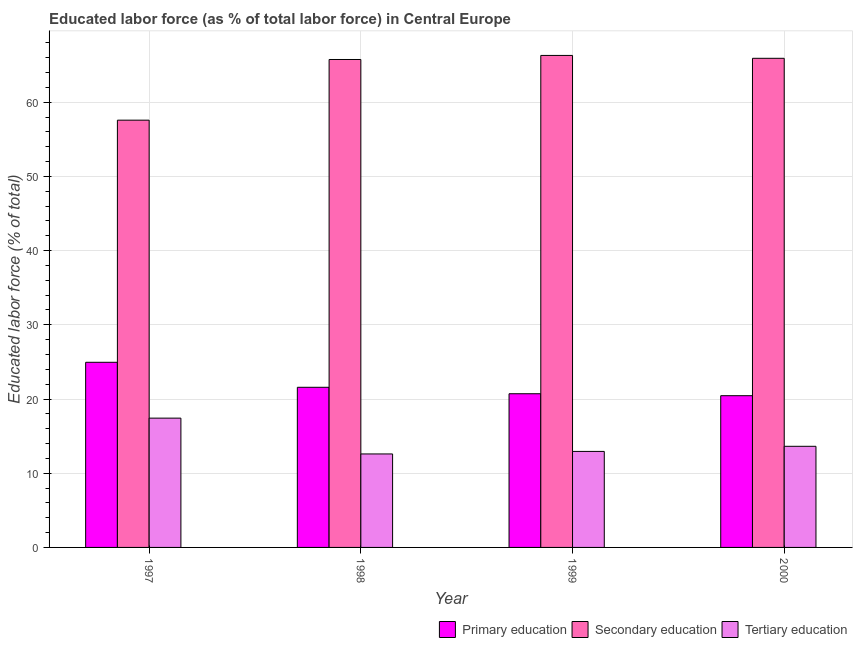How many different coloured bars are there?
Give a very brief answer. 3. Are the number of bars on each tick of the X-axis equal?
Give a very brief answer. Yes. How many bars are there on the 3rd tick from the right?
Offer a terse response. 3. What is the label of the 3rd group of bars from the left?
Offer a very short reply. 1999. What is the percentage of labor force who received primary education in 1997?
Your response must be concise. 24.95. Across all years, what is the maximum percentage of labor force who received tertiary education?
Provide a short and direct response. 17.42. Across all years, what is the minimum percentage of labor force who received tertiary education?
Offer a very short reply. 12.6. In which year was the percentage of labor force who received secondary education maximum?
Offer a very short reply. 1999. What is the total percentage of labor force who received primary education in the graph?
Your response must be concise. 87.69. What is the difference between the percentage of labor force who received secondary education in 1999 and that in 2000?
Provide a succinct answer. 0.39. What is the difference between the percentage of labor force who received tertiary education in 1999 and the percentage of labor force who received primary education in 1998?
Your response must be concise. 0.34. What is the average percentage of labor force who received primary education per year?
Provide a short and direct response. 21.92. In how many years, is the percentage of labor force who received secondary education greater than 24 %?
Keep it short and to the point. 4. What is the ratio of the percentage of labor force who received secondary education in 1997 to that in 1998?
Your answer should be compact. 0.88. What is the difference between the highest and the second highest percentage of labor force who received tertiary education?
Your answer should be very brief. 3.8. What is the difference between the highest and the lowest percentage of labor force who received secondary education?
Provide a short and direct response. 8.72. What does the 2nd bar from the left in 1999 represents?
Your answer should be compact. Secondary education. What does the 1st bar from the right in 1997 represents?
Your answer should be very brief. Tertiary education. Is it the case that in every year, the sum of the percentage of labor force who received primary education and percentage of labor force who received secondary education is greater than the percentage of labor force who received tertiary education?
Offer a terse response. Yes. How many years are there in the graph?
Keep it short and to the point. 4. Are the values on the major ticks of Y-axis written in scientific E-notation?
Make the answer very short. No. Does the graph contain grids?
Provide a short and direct response. Yes. How are the legend labels stacked?
Your answer should be compact. Horizontal. What is the title of the graph?
Provide a succinct answer. Educated labor force (as % of total labor force) in Central Europe. Does "Machinery" appear as one of the legend labels in the graph?
Keep it short and to the point. No. What is the label or title of the X-axis?
Provide a succinct answer. Year. What is the label or title of the Y-axis?
Ensure brevity in your answer.  Educated labor force (% of total). What is the Educated labor force (% of total) of Primary education in 1997?
Offer a very short reply. 24.95. What is the Educated labor force (% of total) of Secondary education in 1997?
Your response must be concise. 57.58. What is the Educated labor force (% of total) of Tertiary education in 1997?
Provide a short and direct response. 17.42. What is the Educated labor force (% of total) of Primary education in 1998?
Provide a succinct answer. 21.58. What is the Educated labor force (% of total) of Secondary education in 1998?
Keep it short and to the point. 65.76. What is the Educated labor force (% of total) in Tertiary education in 1998?
Your answer should be compact. 12.6. What is the Educated labor force (% of total) of Primary education in 1999?
Make the answer very short. 20.71. What is the Educated labor force (% of total) in Secondary education in 1999?
Your response must be concise. 66.3. What is the Educated labor force (% of total) of Tertiary education in 1999?
Offer a terse response. 12.94. What is the Educated labor force (% of total) of Primary education in 2000?
Your answer should be very brief. 20.45. What is the Educated labor force (% of total) of Secondary education in 2000?
Provide a short and direct response. 65.91. What is the Educated labor force (% of total) of Tertiary education in 2000?
Offer a terse response. 13.63. Across all years, what is the maximum Educated labor force (% of total) in Primary education?
Your answer should be compact. 24.95. Across all years, what is the maximum Educated labor force (% of total) in Secondary education?
Keep it short and to the point. 66.3. Across all years, what is the maximum Educated labor force (% of total) in Tertiary education?
Give a very brief answer. 17.42. Across all years, what is the minimum Educated labor force (% of total) of Primary education?
Keep it short and to the point. 20.45. Across all years, what is the minimum Educated labor force (% of total) of Secondary education?
Provide a succinct answer. 57.58. Across all years, what is the minimum Educated labor force (% of total) in Tertiary education?
Your answer should be compact. 12.6. What is the total Educated labor force (% of total) of Primary education in the graph?
Make the answer very short. 87.69. What is the total Educated labor force (% of total) of Secondary education in the graph?
Make the answer very short. 255.55. What is the total Educated labor force (% of total) in Tertiary education in the graph?
Offer a terse response. 56.59. What is the difference between the Educated labor force (% of total) in Primary education in 1997 and that in 1998?
Give a very brief answer. 3.37. What is the difference between the Educated labor force (% of total) of Secondary education in 1997 and that in 1998?
Offer a very short reply. -8.18. What is the difference between the Educated labor force (% of total) in Tertiary education in 1997 and that in 1998?
Ensure brevity in your answer.  4.83. What is the difference between the Educated labor force (% of total) of Primary education in 1997 and that in 1999?
Offer a terse response. 4.24. What is the difference between the Educated labor force (% of total) of Secondary education in 1997 and that in 1999?
Give a very brief answer. -8.72. What is the difference between the Educated labor force (% of total) in Tertiary education in 1997 and that in 1999?
Your response must be concise. 4.48. What is the difference between the Educated labor force (% of total) of Primary education in 1997 and that in 2000?
Your response must be concise. 4.5. What is the difference between the Educated labor force (% of total) of Secondary education in 1997 and that in 2000?
Keep it short and to the point. -8.33. What is the difference between the Educated labor force (% of total) in Tertiary education in 1997 and that in 2000?
Your answer should be compact. 3.8. What is the difference between the Educated labor force (% of total) of Primary education in 1998 and that in 1999?
Give a very brief answer. 0.87. What is the difference between the Educated labor force (% of total) in Secondary education in 1998 and that in 1999?
Your response must be concise. -0.55. What is the difference between the Educated labor force (% of total) in Tertiary education in 1998 and that in 1999?
Offer a very short reply. -0.34. What is the difference between the Educated labor force (% of total) of Primary education in 1998 and that in 2000?
Keep it short and to the point. 1.13. What is the difference between the Educated labor force (% of total) of Secondary education in 1998 and that in 2000?
Your answer should be compact. -0.16. What is the difference between the Educated labor force (% of total) in Tertiary education in 1998 and that in 2000?
Ensure brevity in your answer.  -1.03. What is the difference between the Educated labor force (% of total) in Primary education in 1999 and that in 2000?
Offer a very short reply. 0.26. What is the difference between the Educated labor force (% of total) in Secondary education in 1999 and that in 2000?
Keep it short and to the point. 0.39. What is the difference between the Educated labor force (% of total) of Tertiary education in 1999 and that in 2000?
Ensure brevity in your answer.  -0.69. What is the difference between the Educated labor force (% of total) in Primary education in 1997 and the Educated labor force (% of total) in Secondary education in 1998?
Offer a terse response. -40.81. What is the difference between the Educated labor force (% of total) in Primary education in 1997 and the Educated labor force (% of total) in Tertiary education in 1998?
Provide a short and direct response. 12.35. What is the difference between the Educated labor force (% of total) of Secondary education in 1997 and the Educated labor force (% of total) of Tertiary education in 1998?
Ensure brevity in your answer.  44.98. What is the difference between the Educated labor force (% of total) of Primary education in 1997 and the Educated labor force (% of total) of Secondary education in 1999?
Offer a very short reply. -41.35. What is the difference between the Educated labor force (% of total) of Primary education in 1997 and the Educated labor force (% of total) of Tertiary education in 1999?
Offer a terse response. 12.01. What is the difference between the Educated labor force (% of total) in Secondary education in 1997 and the Educated labor force (% of total) in Tertiary education in 1999?
Give a very brief answer. 44.64. What is the difference between the Educated labor force (% of total) in Primary education in 1997 and the Educated labor force (% of total) in Secondary education in 2000?
Provide a succinct answer. -40.97. What is the difference between the Educated labor force (% of total) in Primary education in 1997 and the Educated labor force (% of total) in Tertiary education in 2000?
Give a very brief answer. 11.32. What is the difference between the Educated labor force (% of total) in Secondary education in 1997 and the Educated labor force (% of total) in Tertiary education in 2000?
Ensure brevity in your answer.  43.95. What is the difference between the Educated labor force (% of total) in Primary education in 1998 and the Educated labor force (% of total) in Secondary education in 1999?
Offer a terse response. -44.72. What is the difference between the Educated labor force (% of total) in Primary education in 1998 and the Educated labor force (% of total) in Tertiary education in 1999?
Your answer should be compact. 8.64. What is the difference between the Educated labor force (% of total) of Secondary education in 1998 and the Educated labor force (% of total) of Tertiary education in 1999?
Give a very brief answer. 52.82. What is the difference between the Educated labor force (% of total) in Primary education in 1998 and the Educated labor force (% of total) in Secondary education in 2000?
Offer a very short reply. -44.33. What is the difference between the Educated labor force (% of total) of Primary education in 1998 and the Educated labor force (% of total) of Tertiary education in 2000?
Provide a short and direct response. 7.95. What is the difference between the Educated labor force (% of total) in Secondary education in 1998 and the Educated labor force (% of total) in Tertiary education in 2000?
Give a very brief answer. 52.13. What is the difference between the Educated labor force (% of total) in Primary education in 1999 and the Educated labor force (% of total) in Secondary education in 2000?
Offer a very short reply. -45.2. What is the difference between the Educated labor force (% of total) in Primary education in 1999 and the Educated labor force (% of total) in Tertiary education in 2000?
Make the answer very short. 7.08. What is the difference between the Educated labor force (% of total) in Secondary education in 1999 and the Educated labor force (% of total) in Tertiary education in 2000?
Your answer should be very brief. 52.68. What is the average Educated labor force (% of total) of Primary education per year?
Provide a succinct answer. 21.92. What is the average Educated labor force (% of total) in Secondary education per year?
Provide a short and direct response. 63.89. What is the average Educated labor force (% of total) of Tertiary education per year?
Keep it short and to the point. 14.15. In the year 1997, what is the difference between the Educated labor force (% of total) in Primary education and Educated labor force (% of total) in Secondary education?
Offer a terse response. -32.63. In the year 1997, what is the difference between the Educated labor force (% of total) in Primary education and Educated labor force (% of total) in Tertiary education?
Your response must be concise. 7.53. In the year 1997, what is the difference between the Educated labor force (% of total) of Secondary education and Educated labor force (% of total) of Tertiary education?
Your answer should be very brief. 40.16. In the year 1998, what is the difference between the Educated labor force (% of total) in Primary education and Educated labor force (% of total) in Secondary education?
Your answer should be very brief. -44.18. In the year 1998, what is the difference between the Educated labor force (% of total) of Primary education and Educated labor force (% of total) of Tertiary education?
Your answer should be very brief. 8.98. In the year 1998, what is the difference between the Educated labor force (% of total) of Secondary education and Educated labor force (% of total) of Tertiary education?
Offer a terse response. 53.16. In the year 1999, what is the difference between the Educated labor force (% of total) in Primary education and Educated labor force (% of total) in Secondary education?
Your answer should be very brief. -45.59. In the year 1999, what is the difference between the Educated labor force (% of total) in Primary education and Educated labor force (% of total) in Tertiary education?
Keep it short and to the point. 7.77. In the year 1999, what is the difference between the Educated labor force (% of total) in Secondary education and Educated labor force (% of total) in Tertiary education?
Give a very brief answer. 53.36. In the year 2000, what is the difference between the Educated labor force (% of total) of Primary education and Educated labor force (% of total) of Secondary education?
Provide a short and direct response. -45.47. In the year 2000, what is the difference between the Educated labor force (% of total) of Primary education and Educated labor force (% of total) of Tertiary education?
Provide a succinct answer. 6.82. In the year 2000, what is the difference between the Educated labor force (% of total) of Secondary education and Educated labor force (% of total) of Tertiary education?
Provide a short and direct response. 52.29. What is the ratio of the Educated labor force (% of total) of Primary education in 1997 to that in 1998?
Make the answer very short. 1.16. What is the ratio of the Educated labor force (% of total) in Secondary education in 1997 to that in 1998?
Keep it short and to the point. 0.88. What is the ratio of the Educated labor force (% of total) in Tertiary education in 1997 to that in 1998?
Your response must be concise. 1.38. What is the ratio of the Educated labor force (% of total) of Primary education in 1997 to that in 1999?
Keep it short and to the point. 1.2. What is the ratio of the Educated labor force (% of total) in Secondary education in 1997 to that in 1999?
Make the answer very short. 0.87. What is the ratio of the Educated labor force (% of total) in Tertiary education in 1997 to that in 1999?
Offer a very short reply. 1.35. What is the ratio of the Educated labor force (% of total) of Primary education in 1997 to that in 2000?
Offer a terse response. 1.22. What is the ratio of the Educated labor force (% of total) of Secondary education in 1997 to that in 2000?
Your answer should be compact. 0.87. What is the ratio of the Educated labor force (% of total) in Tertiary education in 1997 to that in 2000?
Offer a terse response. 1.28. What is the ratio of the Educated labor force (% of total) of Primary education in 1998 to that in 1999?
Give a very brief answer. 1.04. What is the ratio of the Educated labor force (% of total) in Tertiary education in 1998 to that in 1999?
Provide a succinct answer. 0.97. What is the ratio of the Educated labor force (% of total) of Primary education in 1998 to that in 2000?
Provide a short and direct response. 1.06. What is the ratio of the Educated labor force (% of total) in Secondary education in 1998 to that in 2000?
Provide a succinct answer. 1. What is the ratio of the Educated labor force (% of total) in Tertiary education in 1998 to that in 2000?
Make the answer very short. 0.92. What is the ratio of the Educated labor force (% of total) in Primary education in 1999 to that in 2000?
Your answer should be compact. 1.01. What is the ratio of the Educated labor force (% of total) of Secondary education in 1999 to that in 2000?
Keep it short and to the point. 1.01. What is the ratio of the Educated labor force (% of total) in Tertiary education in 1999 to that in 2000?
Make the answer very short. 0.95. What is the difference between the highest and the second highest Educated labor force (% of total) in Primary education?
Keep it short and to the point. 3.37. What is the difference between the highest and the second highest Educated labor force (% of total) in Secondary education?
Your response must be concise. 0.39. What is the difference between the highest and the second highest Educated labor force (% of total) of Tertiary education?
Provide a succinct answer. 3.8. What is the difference between the highest and the lowest Educated labor force (% of total) of Primary education?
Ensure brevity in your answer.  4.5. What is the difference between the highest and the lowest Educated labor force (% of total) of Secondary education?
Provide a succinct answer. 8.72. What is the difference between the highest and the lowest Educated labor force (% of total) of Tertiary education?
Provide a short and direct response. 4.83. 